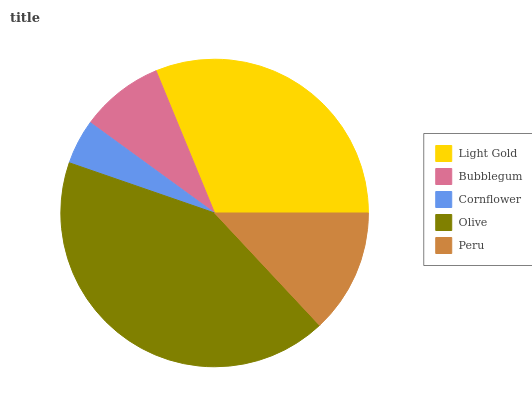Is Cornflower the minimum?
Answer yes or no. Yes. Is Olive the maximum?
Answer yes or no. Yes. Is Bubblegum the minimum?
Answer yes or no. No. Is Bubblegum the maximum?
Answer yes or no. No. Is Light Gold greater than Bubblegum?
Answer yes or no. Yes. Is Bubblegum less than Light Gold?
Answer yes or no. Yes. Is Bubblegum greater than Light Gold?
Answer yes or no. No. Is Light Gold less than Bubblegum?
Answer yes or no. No. Is Peru the high median?
Answer yes or no. Yes. Is Peru the low median?
Answer yes or no. Yes. Is Light Gold the high median?
Answer yes or no. No. Is Bubblegum the low median?
Answer yes or no. No. 